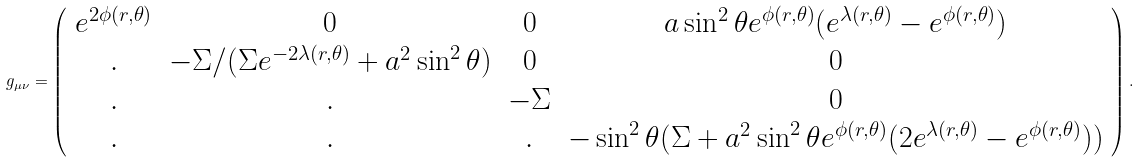Convert formula to latex. <formula><loc_0><loc_0><loc_500><loc_500>g _ { \mu \nu } = \left ( \begin{array} { c c c c } e ^ { 2 \phi ( r , \theta ) } & 0 & 0 & a \sin ^ { 2 } { \theta } e ^ { \phi ( r , \theta ) } ( e ^ { \lambda ( r , \theta ) } - e ^ { \phi ( r , \theta ) } ) \\ . & - \Sigma / ( \Sigma e ^ { - 2 \lambda ( r , \theta ) } + a ^ { 2 } \sin ^ { 2 } { \theta } ) & 0 & 0 \\ . & . & - \Sigma & 0 \\ . & . & . & - \sin ^ { 2 } { \theta } ( \Sigma + a ^ { 2 } \sin ^ { 2 } { \theta } e ^ { \phi ( r , \theta ) } ( 2 e ^ { \lambda ( r , \theta ) } - e ^ { \phi ( r , \theta ) } ) ) \\ \end{array} \right ) .</formula> 